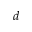<formula> <loc_0><loc_0><loc_500><loc_500>d</formula> 